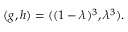Convert formula to latex. <formula><loc_0><loc_0><loc_500><loc_500>( g , h ) = ( ( 1 - \lambda ) ^ { 3 } , \lambda ^ { 3 } ) .</formula> 